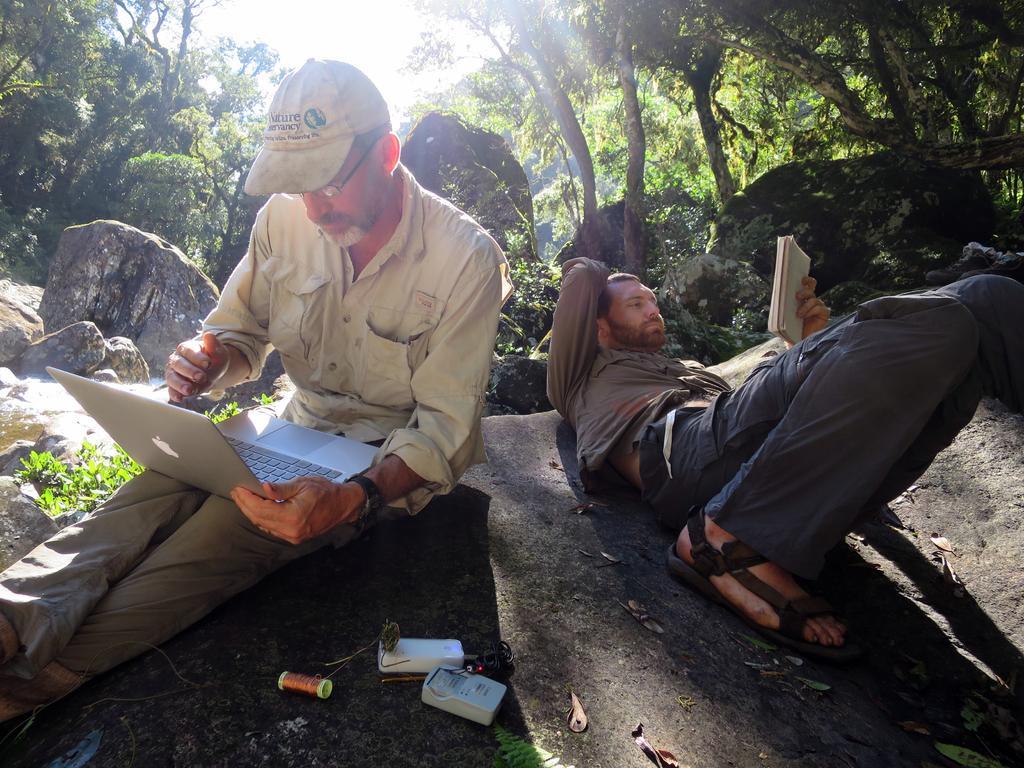Could you give a brief overview of what you see in this image? In this image there are two men in the middle. The man on the left side is sitting on the stone and working with the laptop. The man on the right side is sleeping on the stone while reading the book. In the background there are stones and trees. 